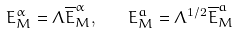Convert formula to latex. <formula><loc_0><loc_0><loc_500><loc_500>E _ { M } ^ { \alpha } = \Lambda \overline { E } _ { M } ^ { \alpha } , \quad E _ { M } ^ { a } = \Lambda ^ { 1 / 2 } \overline { E } _ { M } ^ { a }</formula> 